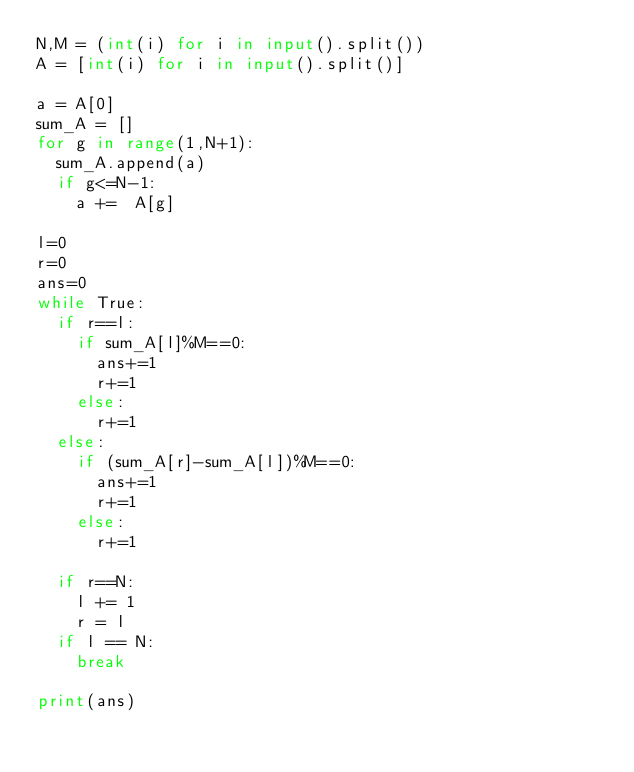Convert code to text. <code><loc_0><loc_0><loc_500><loc_500><_Python_>N,M = (int(i) for i in input().split())  
A = [int(i) for i in input().split()]

a = A[0]
sum_A = []
for g in range(1,N+1):
	sum_A.append(a)
	if g<=N-1:
		a +=  A[g]

l=0
r=0
ans=0
while True:
	if r==l:
		if sum_A[l]%M==0:
			ans+=1
			r+=1
		else:
			r+=1
	else:
		if (sum_A[r]-sum_A[l])%M==0:
			ans+=1
			r+=1
		else:
			r+=1

	if r==N:
		l += 1
		r = l
	if l == N:
		break

print(ans)</code> 